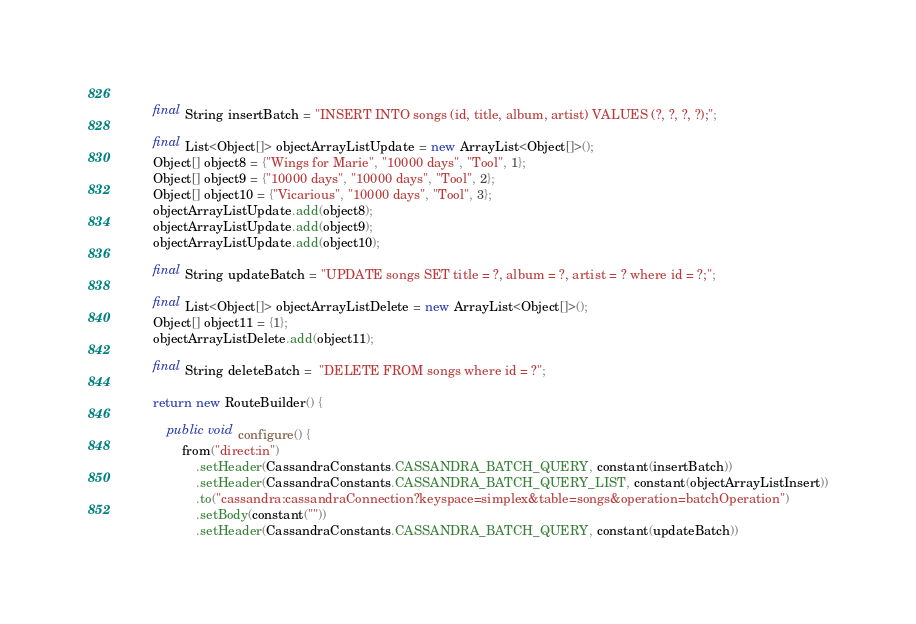Convert code to text. <code><loc_0><loc_0><loc_500><loc_500><_Java_>        
        final String insertBatch = "INSERT INTO songs (id, title, album, artist) VALUES (?, ?, ?, ?);";
        
        final List<Object[]> objectArrayListUpdate = new ArrayList<Object[]>();
        Object[] object8 = {"Wings for Marie", "10000 days", "Tool", 1};
        Object[] object9 = {"10000 days", "10000 days", "Tool", 2};
        Object[] object10 = {"Vicarious", "10000 days", "Tool", 3};
        objectArrayListUpdate.add(object8);
        objectArrayListUpdate.add(object9);
        objectArrayListUpdate.add(object10);
        
        final String updateBatch = "UPDATE songs SET title = ?, album = ?, artist = ? where id = ?;";
        
        final List<Object[]> objectArrayListDelete = new ArrayList<Object[]>();
        Object[] object11 = {1};
        objectArrayListDelete.add(object11);
        
        final String deleteBatch =  "DELETE FROM songs where id = ?";
        
        return new RouteBuilder() {
            
            public void configure() {
                from("direct:in")
                	.setHeader(CassandraConstants.CASSANDRA_BATCH_QUERY, constant(insertBatch))
                	.setHeader(CassandraConstants.CASSANDRA_BATCH_QUERY_LIST, constant(objectArrayListInsert))
                    .to("cassandra:cassandraConnection?keyspace=simplex&table=songs&operation=batchOperation")
                    .setBody(constant(""))
                	.setHeader(CassandraConstants.CASSANDRA_BATCH_QUERY, constant(updateBatch))</code> 